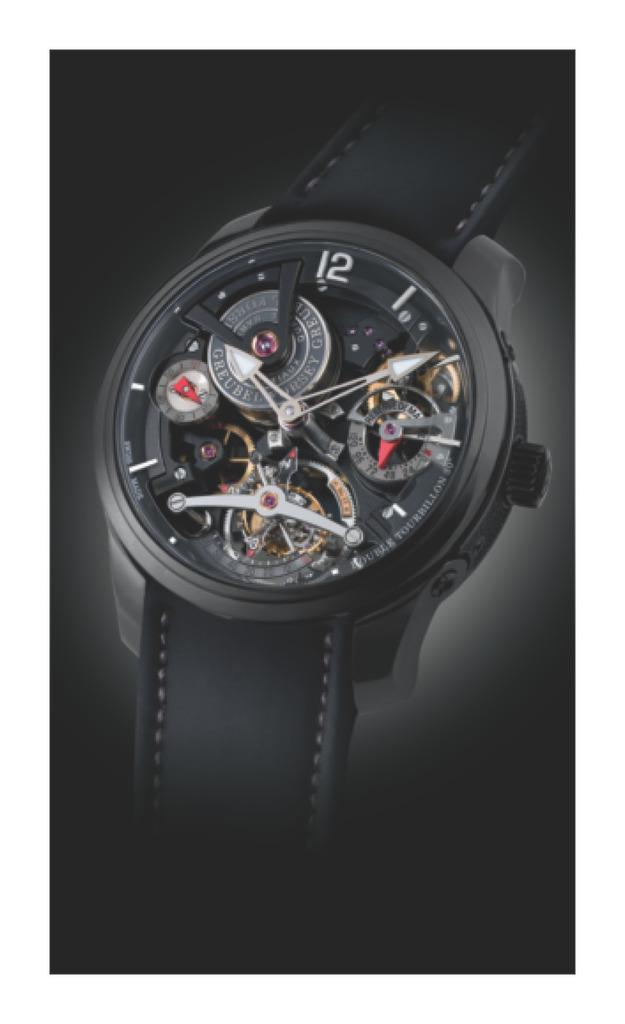What digits can be seen on the watch?
Offer a very short reply. 12. 